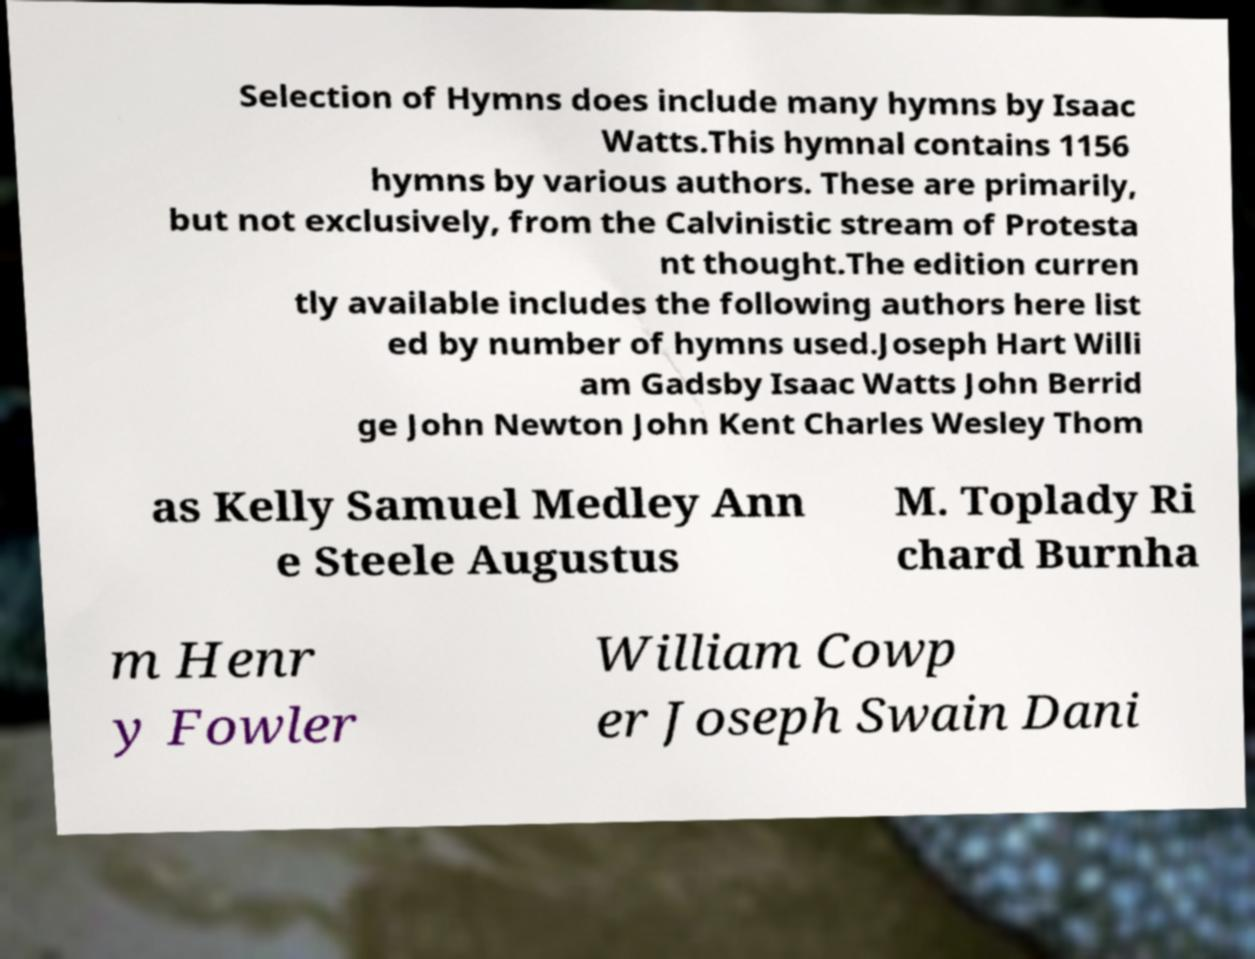Could you extract and type out the text from this image? Selection of Hymns does include many hymns by Isaac Watts.This hymnal contains 1156 hymns by various authors. These are primarily, but not exclusively, from the Calvinistic stream of Protesta nt thought.The edition curren tly available includes the following authors here list ed by number of hymns used.Joseph Hart Willi am Gadsby Isaac Watts John Berrid ge John Newton John Kent Charles Wesley Thom as Kelly Samuel Medley Ann e Steele Augustus M. Toplady Ri chard Burnha m Henr y Fowler William Cowp er Joseph Swain Dani 